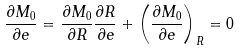<formula> <loc_0><loc_0><loc_500><loc_500>\frac { \partial M _ { 0 } } { \partial e } = \frac { \partial M _ { 0 } } { \partial R } \frac { \partial R } { \partial e } + \left ( \frac { \partial M _ { 0 } } { \partial e } \right ) _ { R } = 0</formula> 